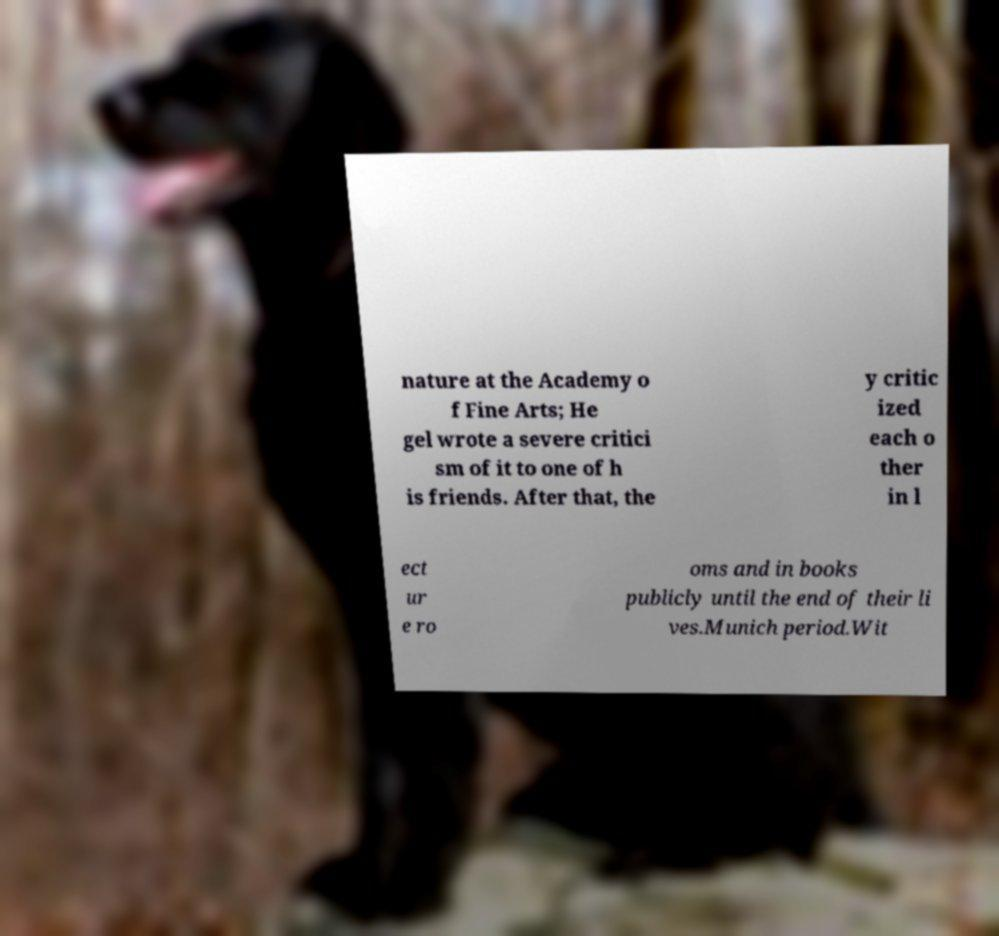What messages or text are displayed in this image? I need them in a readable, typed format. nature at the Academy o f Fine Arts; He gel wrote a severe critici sm of it to one of h is friends. After that, the y critic ized each o ther in l ect ur e ro oms and in books publicly until the end of their li ves.Munich period.Wit 